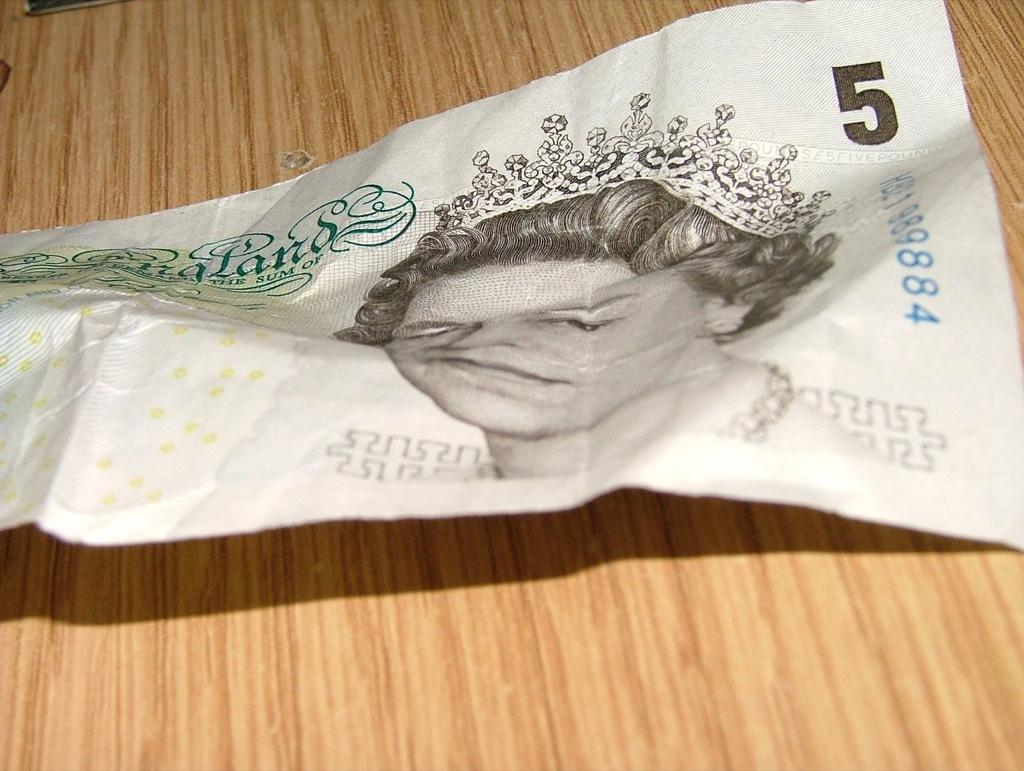What is the main object in the image? There is a currency note in the image. What type of surface is the currency note placed on? There is a wooden desk in the image. What type of amusement can be seen in the image? There is no amusement present in the image; it only features a currency note on a wooden desk. Is there a van visible in the image? No, there is no van present in the image. 